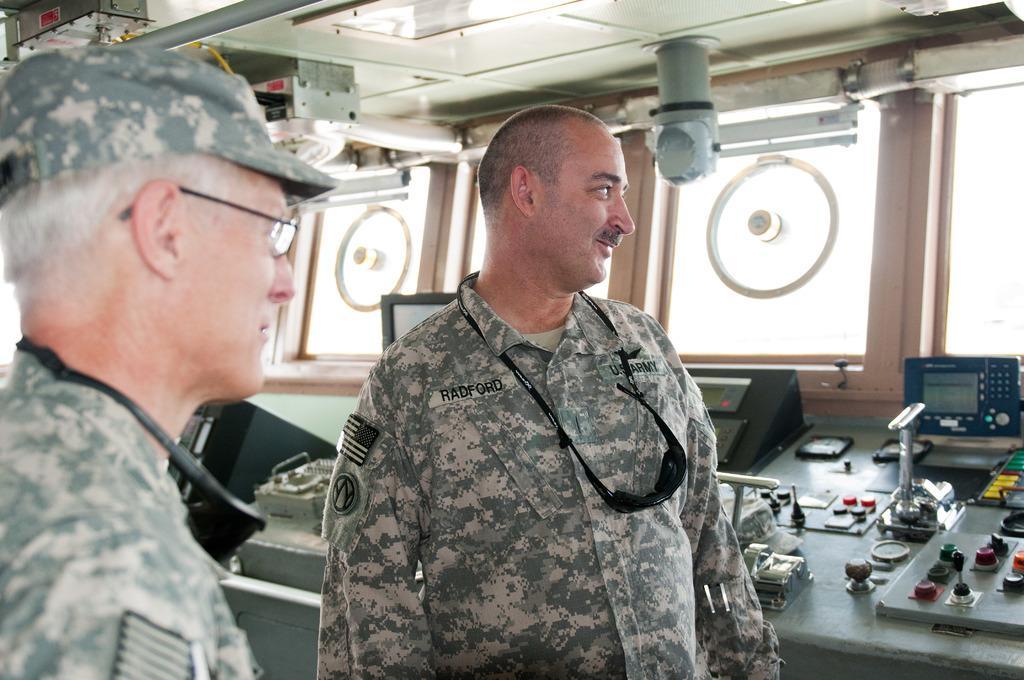Could you give a brief overview of what you see in this image? In this picture we can see two army people, behind we can see some machinery things placed on the table. 